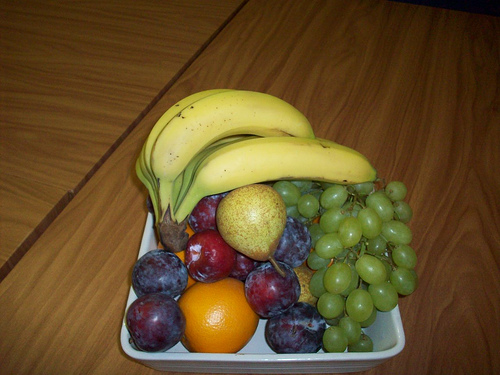<image>What part of the fruit pictured was thrown out? It is unclear what part of the fruit was thrown out. It could be the grapes, stems, or nothing. What expression is the banana making? It is ambiguous to determine the expression of the banana because bananas do not have expressions. What part of the fruit pictured was thrown out? I don't know what part of the fruit pictured was thrown out. It can be either grapes or stems. What expression is the banana making? I am not sure what expression the banana is making. It can be seen as making a frown, sad or solemn expression. 